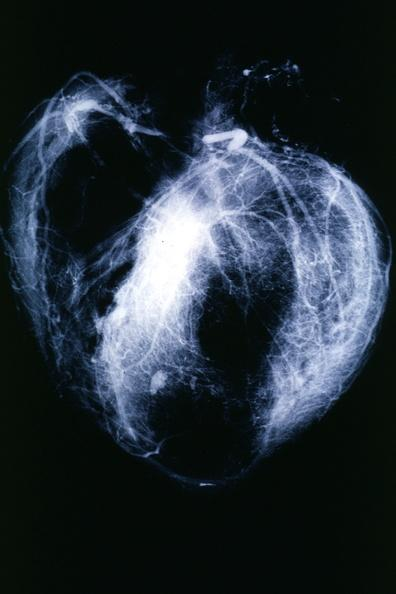what is present?
Answer the question using a single word or phrase. Cardiovascular 